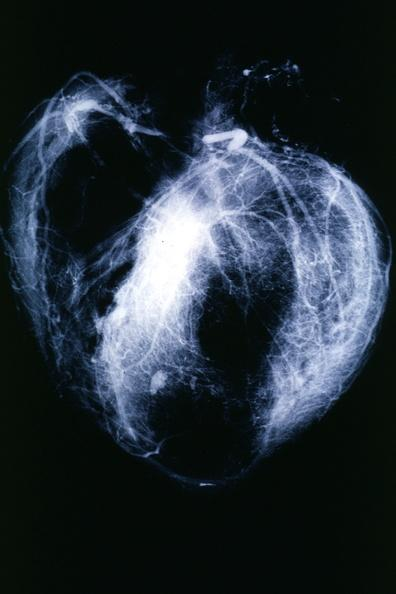what is present?
Answer the question using a single word or phrase. Cardiovascular 